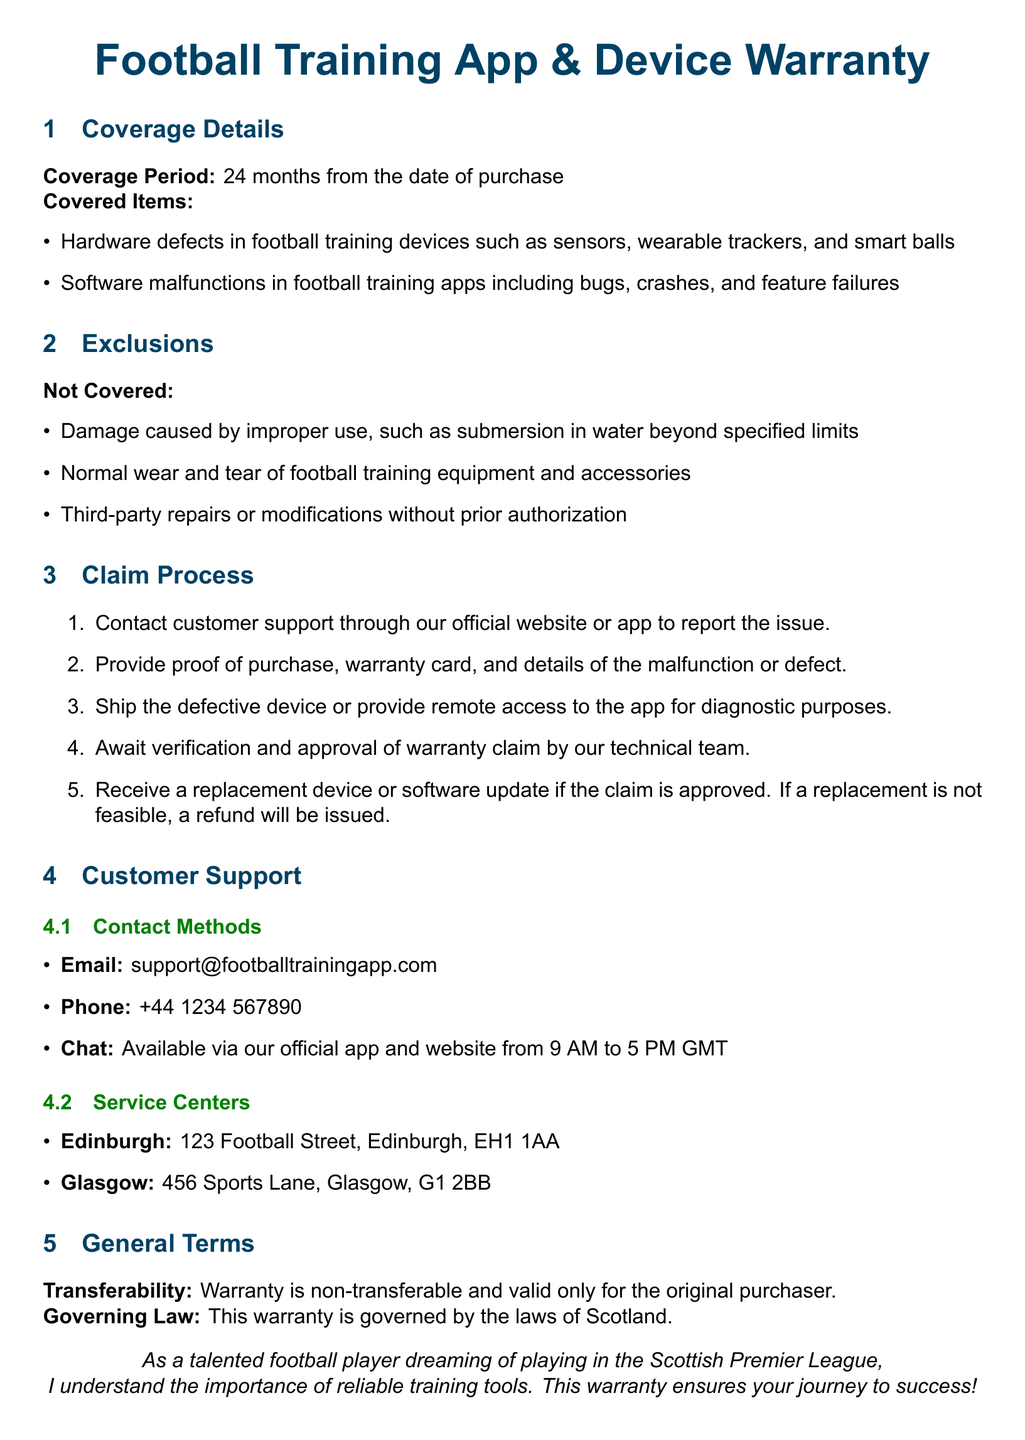what is the coverage period for the warranty? The warranty coverage period is stated as 24 months from the date of purchase.
Answer: 24 months what items are covered under the warranty? The document specifies that hardware defects in training devices and software malfunctions in apps are covered.
Answer: Hardware defects in training devices and software malfunctions in apps what is excluded from the warranty coverage? The document lists specific exclusions such as damage from improper use and normal wear and tear.
Answer: Damage caused by improper use, normal wear and tear how can a customer contact support? The contact methods include email, phone, and chat through the app or website.
Answer: Email, phone, chat what must be provided when making a warranty claim? The document states that proof of purchase, warranty card, and details of the malfunction are required.
Answer: Proof of purchase, warranty card, details of the malfunction what happens if a warranty claim is not approved? It mentions that if a replacement is not feasible, a refund will be issued.
Answer: A refund will be issued in which cities are service centers located? The document lists Edinburgh and Glasgow as the cities where service centers are located.
Answer: Edinburgh and Glasgow is the warranty transferable? The warranty details indicate that the warranty is non-transferable and valid only for the original purchaser.
Answer: Non-transferable which law governs the warranty? The document specifies that the warranty is governed by the laws of Scotland.
Answer: Laws of Scotland 